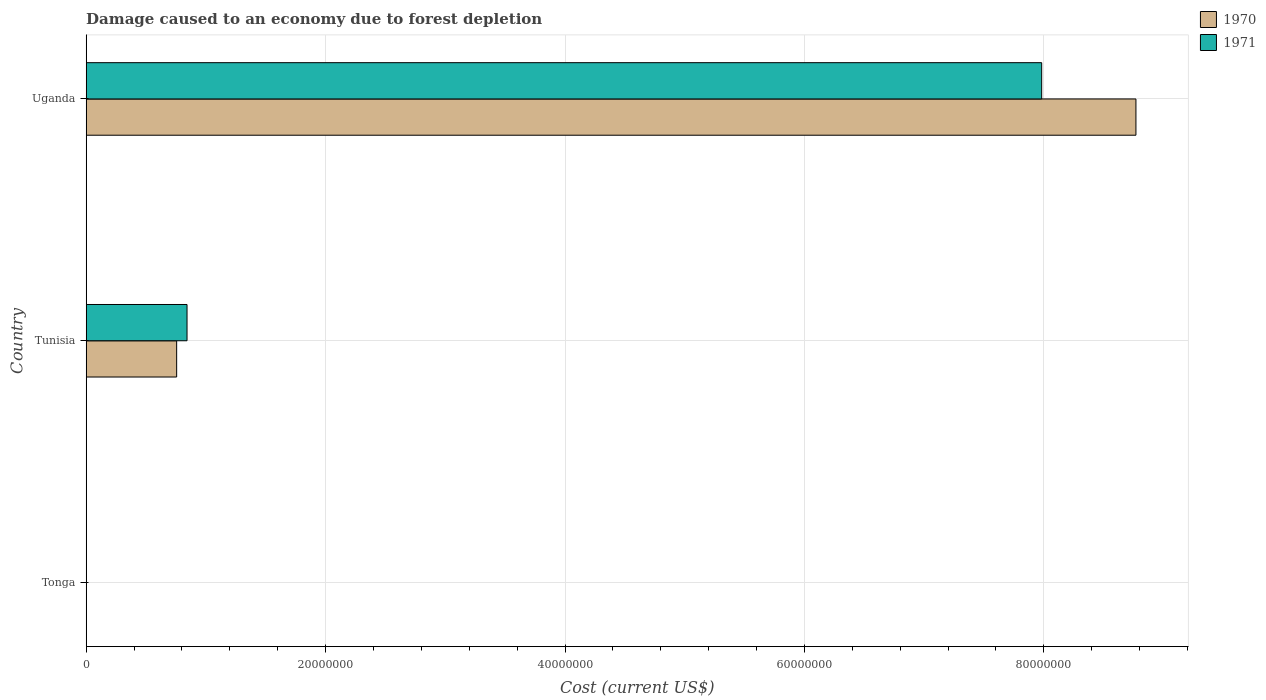Are the number of bars per tick equal to the number of legend labels?
Keep it short and to the point. Yes. What is the label of the 2nd group of bars from the top?
Provide a short and direct response. Tunisia. In how many cases, is the number of bars for a given country not equal to the number of legend labels?
Offer a terse response. 0. What is the cost of damage caused due to forest depletion in 1971 in Tunisia?
Your answer should be very brief. 8.42e+06. Across all countries, what is the maximum cost of damage caused due to forest depletion in 1971?
Offer a terse response. 7.98e+07. Across all countries, what is the minimum cost of damage caused due to forest depletion in 1970?
Your answer should be compact. 4901.94. In which country was the cost of damage caused due to forest depletion in 1971 maximum?
Provide a short and direct response. Uganda. In which country was the cost of damage caused due to forest depletion in 1971 minimum?
Keep it short and to the point. Tonga. What is the total cost of damage caused due to forest depletion in 1971 in the graph?
Ensure brevity in your answer.  8.82e+07. What is the difference between the cost of damage caused due to forest depletion in 1970 in Tonga and that in Tunisia?
Keep it short and to the point. -7.55e+06. What is the difference between the cost of damage caused due to forest depletion in 1970 in Tonga and the cost of damage caused due to forest depletion in 1971 in Tunisia?
Make the answer very short. -8.42e+06. What is the average cost of damage caused due to forest depletion in 1970 per country?
Make the answer very short. 3.18e+07. What is the difference between the cost of damage caused due to forest depletion in 1971 and cost of damage caused due to forest depletion in 1970 in Tunisia?
Your answer should be very brief. 8.66e+05. What is the ratio of the cost of damage caused due to forest depletion in 1971 in Tonga to that in Uganda?
Keep it short and to the point. 5.482819073957733e-5. Is the difference between the cost of damage caused due to forest depletion in 1971 in Tonga and Tunisia greater than the difference between the cost of damage caused due to forest depletion in 1970 in Tonga and Tunisia?
Offer a terse response. No. What is the difference between the highest and the second highest cost of damage caused due to forest depletion in 1971?
Provide a succinct answer. 7.14e+07. What is the difference between the highest and the lowest cost of damage caused due to forest depletion in 1970?
Your answer should be compact. 8.77e+07. In how many countries, is the cost of damage caused due to forest depletion in 1970 greater than the average cost of damage caused due to forest depletion in 1970 taken over all countries?
Provide a succinct answer. 1. Is the sum of the cost of damage caused due to forest depletion in 1970 in Tunisia and Uganda greater than the maximum cost of damage caused due to forest depletion in 1971 across all countries?
Your answer should be very brief. Yes. What does the 1st bar from the top in Tunisia represents?
Provide a succinct answer. 1971. What does the 1st bar from the bottom in Tunisia represents?
Offer a terse response. 1970. How many bars are there?
Provide a short and direct response. 6. Are all the bars in the graph horizontal?
Provide a short and direct response. Yes. What is the title of the graph?
Ensure brevity in your answer.  Damage caused to an economy due to forest depletion. Does "2013" appear as one of the legend labels in the graph?
Your answer should be very brief. No. What is the label or title of the X-axis?
Offer a very short reply. Cost (current US$). What is the Cost (current US$) in 1970 in Tonga?
Give a very brief answer. 4901.94. What is the Cost (current US$) of 1971 in Tonga?
Provide a short and direct response. 4376.43. What is the Cost (current US$) of 1970 in Tunisia?
Your answer should be very brief. 7.56e+06. What is the Cost (current US$) of 1971 in Tunisia?
Provide a short and direct response. 8.42e+06. What is the Cost (current US$) of 1970 in Uganda?
Make the answer very short. 8.77e+07. What is the Cost (current US$) of 1971 in Uganda?
Ensure brevity in your answer.  7.98e+07. Across all countries, what is the maximum Cost (current US$) of 1970?
Provide a short and direct response. 8.77e+07. Across all countries, what is the maximum Cost (current US$) in 1971?
Ensure brevity in your answer.  7.98e+07. Across all countries, what is the minimum Cost (current US$) in 1970?
Keep it short and to the point. 4901.94. Across all countries, what is the minimum Cost (current US$) in 1971?
Your response must be concise. 4376.43. What is the total Cost (current US$) of 1970 in the graph?
Keep it short and to the point. 9.53e+07. What is the total Cost (current US$) of 1971 in the graph?
Ensure brevity in your answer.  8.82e+07. What is the difference between the Cost (current US$) in 1970 in Tonga and that in Tunisia?
Give a very brief answer. -7.55e+06. What is the difference between the Cost (current US$) of 1971 in Tonga and that in Tunisia?
Give a very brief answer. -8.42e+06. What is the difference between the Cost (current US$) of 1970 in Tonga and that in Uganda?
Provide a short and direct response. -8.77e+07. What is the difference between the Cost (current US$) of 1971 in Tonga and that in Uganda?
Ensure brevity in your answer.  -7.98e+07. What is the difference between the Cost (current US$) of 1970 in Tunisia and that in Uganda?
Your answer should be compact. -8.01e+07. What is the difference between the Cost (current US$) of 1971 in Tunisia and that in Uganda?
Offer a very short reply. -7.14e+07. What is the difference between the Cost (current US$) in 1970 in Tonga and the Cost (current US$) in 1971 in Tunisia?
Keep it short and to the point. -8.42e+06. What is the difference between the Cost (current US$) in 1970 in Tonga and the Cost (current US$) in 1971 in Uganda?
Keep it short and to the point. -7.98e+07. What is the difference between the Cost (current US$) of 1970 in Tunisia and the Cost (current US$) of 1971 in Uganda?
Make the answer very short. -7.23e+07. What is the average Cost (current US$) of 1970 per country?
Make the answer very short. 3.18e+07. What is the average Cost (current US$) of 1971 per country?
Provide a succinct answer. 2.94e+07. What is the difference between the Cost (current US$) of 1970 and Cost (current US$) of 1971 in Tonga?
Provide a short and direct response. 525.51. What is the difference between the Cost (current US$) in 1970 and Cost (current US$) in 1971 in Tunisia?
Offer a terse response. -8.66e+05. What is the difference between the Cost (current US$) of 1970 and Cost (current US$) of 1971 in Uganda?
Make the answer very short. 7.87e+06. What is the ratio of the Cost (current US$) in 1970 in Tonga to that in Tunisia?
Your answer should be very brief. 0. What is the ratio of the Cost (current US$) of 1971 in Tonga to that in Tunisia?
Keep it short and to the point. 0. What is the ratio of the Cost (current US$) in 1970 in Tonga to that in Uganda?
Provide a short and direct response. 0. What is the ratio of the Cost (current US$) in 1971 in Tonga to that in Uganda?
Ensure brevity in your answer.  0. What is the ratio of the Cost (current US$) in 1970 in Tunisia to that in Uganda?
Provide a short and direct response. 0.09. What is the ratio of the Cost (current US$) in 1971 in Tunisia to that in Uganda?
Provide a succinct answer. 0.11. What is the difference between the highest and the second highest Cost (current US$) in 1970?
Your answer should be compact. 8.01e+07. What is the difference between the highest and the second highest Cost (current US$) of 1971?
Provide a short and direct response. 7.14e+07. What is the difference between the highest and the lowest Cost (current US$) of 1970?
Keep it short and to the point. 8.77e+07. What is the difference between the highest and the lowest Cost (current US$) in 1971?
Your answer should be compact. 7.98e+07. 